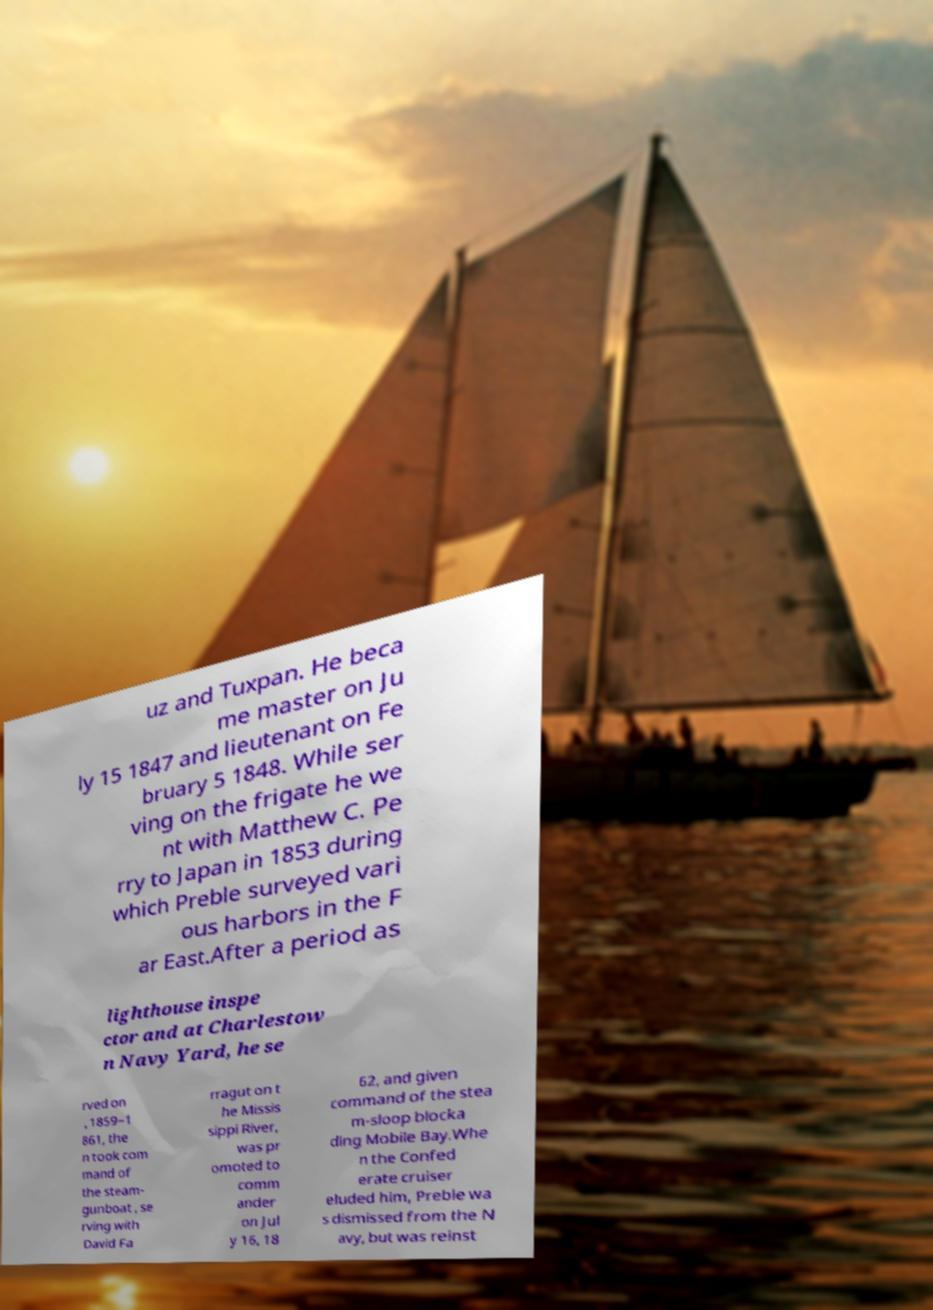Please read and relay the text visible in this image. What does it say? uz and Tuxpan. He beca me master on Ju ly 15 1847 and lieutenant on Fe bruary 5 1848. While ser ving on the frigate he we nt with Matthew C. Pe rry to Japan in 1853 during which Preble surveyed vari ous harbors in the F ar East.After a period as lighthouse inspe ctor and at Charlestow n Navy Yard, he se rved on , 1859–1 861, the n took com mand of the steam- gunboat , se rving with David Fa rragut on t he Missis sippi River, was pr omoted to comm ander on Jul y 16, 18 62, and given command of the stea m-sloop blocka ding Mobile Bay.Whe n the Confed erate cruiser eluded him, Preble wa s dismissed from the N avy, but was reinst 